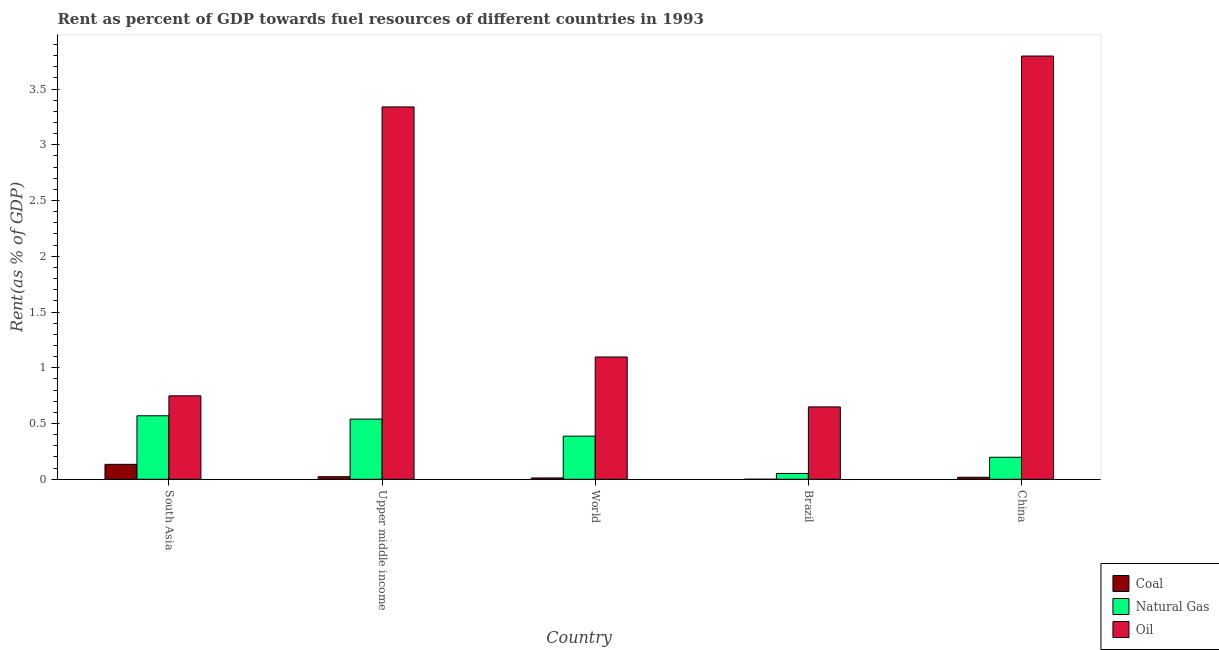How many different coloured bars are there?
Your answer should be very brief. 3. Are the number of bars on each tick of the X-axis equal?
Provide a short and direct response. Yes. In how many cases, is the number of bars for a given country not equal to the number of legend labels?
Offer a terse response. 0. What is the rent towards natural gas in World?
Your answer should be compact. 0.39. Across all countries, what is the maximum rent towards oil?
Provide a succinct answer. 3.8. Across all countries, what is the minimum rent towards coal?
Your answer should be very brief. 0. In which country was the rent towards coal maximum?
Give a very brief answer. South Asia. In which country was the rent towards natural gas minimum?
Make the answer very short. Brazil. What is the total rent towards coal in the graph?
Offer a terse response. 0.19. What is the difference between the rent towards natural gas in Brazil and that in China?
Make the answer very short. -0.15. What is the difference between the rent towards oil in Upper middle income and the rent towards natural gas in World?
Keep it short and to the point. 2.95. What is the average rent towards coal per country?
Offer a terse response. 0.04. What is the difference between the rent towards oil and rent towards coal in Brazil?
Provide a short and direct response. 0.65. In how many countries, is the rent towards oil greater than 0.8 %?
Your answer should be very brief. 3. What is the ratio of the rent towards oil in China to that in World?
Give a very brief answer. 3.46. Is the rent towards coal in South Asia less than that in World?
Offer a very short reply. No. Is the difference between the rent towards natural gas in Brazil and South Asia greater than the difference between the rent towards oil in Brazil and South Asia?
Your response must be concise. No. What is the difference between the highest and the second highest rent towards natural gas?
Provide a succinct answer. 0.03. What is the difference between the highest and the lowest rent towards natural gas?
Offer a terse response. 0.52. In how many countries, is the rent towards natural gas greater than the average rent towards natural gas taken over all countries?
Provide a short and direct response. 3. What does the 3rd bar from the left in Upper middle income represents?
Make the answer very short. Oil. What does the 1st bar from the right in China represents?
Your response must be concise. Oil. What is the difference between two consecutive major ticks on the Y-axis?
Your answer should be compact. 0.5. What is the title of the graph?
Offer a very short reply. Rent as percent of GDP towards fuel resources of different countries in 1993. Does "Agriculture" appear as one of the legend labels in the graph?
Your answer should be very brief. No. What is the label or title of the Y-axis?
Provide a succinct answer. Rent(as % of GDP). What is the Rent(as % of GDP) of Coal in South Asia?
Your response must be concise. 0.13. What is the Rent(as % of GDP) in Natural Gas in South Asia?
Provide a succinct answer. 0.57. What is the Rent(as % of GDP) in Oil in South Asia?
Your answer should be very brief. 0.75. What is the Rent(as % of GDP) of Coal in Upper middle income?
Your answer should be very brief. 0.02. What is the Rent(as % of GDP) of Natural Gas in Upper middle income?
Give a very brief answer. 0.54. What is the Rent(as % of GDP) of Oil in Upper middle income?
Give a very brief answer. 3.34. What is the Rent(as % of GDP) of Coal in World?
Make the answer very short. 0.01. What is the Rent(as % of GDP) of Natural Gas in World?
Offer a terse response. 0.39. What is the Rent(as % of GDP) in Oil in World?
Your response must be concise. 1.1. What is the Rent(as % of GDP) in Coal in Brazil?
Your response must be concise. 0. What is the Rent(as % of GDP) of Natural Gas in Brazil?
Provide a short and direct response. 0.05. What is the Rent(as % of GDP) in Oil in Brazil?
Provide a short and direct response. 0.65. What is the Rent(as % of GDP) of Coal in China?
Ensure brevity in your answer.  0.02. What is the Rent(as % of GDP) in Natural Gas in China?
Give a very brief answer. 0.2. What is the Rent(as % of GDP) of Oil in China?
Ensure brevity in your answer.  3.8. Across all countries, what is the maximum Rent(as % of GDP) in Coal?
Ensure brevity in your answer.  0.13. Across all countries, what is the maximum Rent(as % of GDP) of Natural Gas?
Keep it short and to the point. 0.57. Across all countries, what is the maximum Rent(as % of GDP) of Oil?
Your answer should be very brief. 3.8. Across all countries, what is the minimum Rent(as % of GDP) in Coal?
Give a very brief answer. 0. Across all countries, what is the minimum Rent(as % of GDP) in Natural Gas?
Ensure brevity in your answer.  0.05. Across all countries, what is the minimum Rent(as % of GDP) of Oil?
Offer a very short reply. 0.65. What is the total Rent(as % of GDP) in Coal in the graph?
Provide a succinct answer. 0.19. What is the total Rent(as % of GDP) of Natural Gas in the graph?
Provide a short and direct response. 1.75. What is the total Rent(as % of GDP) in Oil in the graph?
Your response must be concise. 9.63. What is the difference between the Rent(as % of GDP) of Coal in South Asia and that in Upper middle income?
Provide a short and direct response. 0.11. What is the difference between the Rent(as % of GDP) of Natural Gas in South Asia and that in Upper middle income?
Offer a very short reply. 0.03. What is the difference between the Rent(as % of GDP) of Oil in South Asia and that in Upper middle income?
Your response must be concise. -2.59. What is the difference between the Rent(as % of GDP) in Coal in South Asia and that in World?
Make the answer very short. 0.12. What is the difference between the Rent(as % of GDP) in Natural Gas in South Asia and that in World?
Offer a very short reply. 0.18. What is the difference between the Rent(as % of GDP) of Oil in South Asia and that in World?
Provide a short and direct response. -0.35. What is the difference between the Rent(as % of GDP) of Coal in South Asia and that in Brazil?
Make the answer very short. 0.13. What is the difference between the Rent(as % of GDP) of Natural Gas in South Asia and that in Brazil?
Provide a succinct answer. 0.52. What is the difference between the Rent(as % of GDP) in Oil in South Asia and that in Brazil?
Make the answer very short. 0.1. What is the difference between the Rent(as % of GDP) in Coal in South Asia and that in China?
Your answer should be very brief. 0.12. What is the difference between the Rent(as % of GDP) in Natural Gas in South Asia and that in China?
Your answer should be very brief. 0.37. What is the difference between the Rent(as % of GDP) of Oil in South Asia and that in China?
Make the answer very short. -3.05. What is the difference between the Rent(as % of GDP) in Coal in Upper middle income and that in World?
Your answer should be compact. 0.01. What is the difference between the Rent(as % of GDP) in Natural Gas in Upper middle income and that in World?
Ensure brevity in your answer.  0.15. What is the difference between the Rent(as % of GDP) of Oil in Upper middle income and that in World?
Ensure brevity in your answer.  2.24. What is the difference between the Rent(as % of GDP) of Coal in Upper middle income and that in Brazil?
Offer a very short reply. 0.02. What is the difference between the Rent(as % of GDP) of Natural Gas in Upper middle income and that in Brazil?
Your answer should be very brief. 0.49. What is the difference between the Rent(as % of GDP) in Oil in Upper middle income and that in Brazil?
Make the answer very short. 2.69. What is the difference between the Rent(as % of GDP) in Coal in Upper middle income and that in China?
Offer a terse response. 0.01. What is the difference between the Rent(as % of GDP) of Natural Gas in Upper middle income and that in China?
Make the answer very short. 0.34. What is the difference between the Rent(as % of GDP) in Oil in Upper middle income and that in China?
Your answer should be very brief. -0.46. What is the difference between the Rent(as % of GDP) in Coal in World and that in Brazil?
Ensure brevity in your answer.  0.01. What is the difference between the Rent(as % of GDP) in Natural Gas in World and that in Brazil?
Your answer should be very brief. 0.33. What is the difference between the Rent(as % of GDP) of Oil in World and that in Brazil?
Offer a terse response. 0.45. What is the difference between the Rent(as % of GDP) in Coal in World and that in China?
Make the answer very short. -0.01. What is the difference between the Rent(as % of GDP) of Natural Gas in World and that in China?
Make the answer very short. 0.19. What is the difference between the Rent(as % of GDP) in Oil in World and that in China?
Keep it short and to the point. -2.7. What is the difference between the Rent(as % of GDP) of Coal in Brazil and that in China?
Your answer should be very brief. -0.02. What is the difference between the Rent(as % of GDP) in Natural Gas in Brazil and that in China?
Provide a succinct answer. -0.15. What is the difference between the Rent(as % of GDP) in Oil in Brazil and that in China?
Ensure brevity in your answer.  -3.15. What is the difference between the Rent(as % of GDP) of Coal in South Asia and the Rent(as % of GDP) of Natural Gas in Upper middle income?
Make the answer very short. -0.41. What is the difference between the Rent(as % of GDP) in Coal in South Asia and the Rent(as % of GDP) in Oil in Upper middle income?
Your response must be concise. -3.21. What is the difference between the Rent(as % of GDP) of Natural Gas in South Asia and the Rent(as % of GDP) of Oil in Upper middle income?
Make the answer very short. -2.77. What is the difference between the Rent(as % of GDP) in Coal in South Asia and the Rent(as % of GDP) in Natural Gas in World?
Make the answer very short. -0.25. What is the difference between the Rent(as % of GDP) of Coal in South Asia and the Rent(as % of GDP) of Oil in World?
Make the answer very short. -0.96. What is the difference between the Rent(as % of GDP) of Natural Gas in South Asia and the Rent(as % of GDP) of Oil in World?
Give a very brief answer. -0.53. What is the difference between the Rent(as % of GDP) in Coal in South Asia and the Rent(as % of GDP) in Natural Gas in Brazil?
Keep it short and to the point. 0.08. What is the difference between the Rent(as % of GDP) in Coal in South Asia and the Rent(as % of GDP) in Oil in Brazil?
Provide a short and direct response. -0.52. What is the difference between the Rent(as % of GDP) in Natural Gas in South Asia and the Rent(as % of GDP) in Oil in Brazil?
Make the answer very short. -0.08. What is the difference between the Rent(as % of GDP) of Coal in South Asia and the Rent(as % of GDP) of Natural Gas in China?
Provide a short and direct response. -0.06. What is the difference between the Rent(as % of GDP) in Coal in South Asia and the Rent(as % of GDP) in Oil in China?
Make the answer very short. -3.66. What is the difference between the Rent(as % of GDP) of Natural Gas in South Asia and the Rent(as % of GDP) of Oil in China?
Your answer should be compact. -3.23. What is the difference between the Rent(as % of GDP) in Coal in Upper middle income and the Rent(as % of GDP) in Natural Gas in World?
Offer a very short reply. -0.36. What is the difference between the Rent(as % of GDP) in Coal in Upper middle income and the Rent(as % of GDP) in Oil in World?
Provide a succinct answer. -1.07. What is the difference between the Rent(as % of GDP) in Natural Gas in Upper middle income and the Rent(as % of GDP) in Oil in World?
Offer a very short reply. -0.56. What is the difference between the Rent(as % of GDP) in Coal in Upper middle income and the Rent(as % of GDP) in Natural Gas in Brazil?
Offer a very short reply. -0.03. What is the difference between the Rent(as % of GDP) of Coal in Upper middle income and the Rent(as % of GDP) of Oil in Brazil?
Offer a terse response. -0.63. What is the difference between the Rent(as % of GDP) of Natural Gas in Upper middle income and the Rent(as % of GDP) of Oil in Brazil?
Your response must be concise. -0.11. What is the difference between the Rent(as % of GDP) of Coal in Upper middle income and the Rent(as % of GDP) of Natural Gas in China?
Keep it short and to the point. -0.17. What is the difference between the Rent(as % of GDP) of Coal in Upper middle income and the Rent(as % of GDP) of Oil in China?
Provide a succinct answer. -3.77. What is the difference between the Rent(as % of GDP) of Natural Gas in Upper middle income and the Rent(as % of GDP) of Oil in China?
Give a very brief answer. -3.26. What is the difference between the Rent(as % of GDP) of Coal in World and the Rent(as % of GDP) of Natural Gas in Brazil?
Provide a succinct answer. -0.04. What is the difference between the Rent(as % of GDP) of Coal in World and the Rent(as % of GDP) of Oil in Brazil?
Offer a terse response. -0.64. What is the difference between the Rent(as % of GDP) in Natural Gas in World and the Rent(as % of GDP) in Oil in Brazil?
Your response must be concise. -0.26. What is the difference between the Rent(as % of GDP) in Coal in World and the Rent(as % of GDP) in Natural Gas in China?
Offer a terse response. -0.19. What is the difference between the Rent(as % of GDP) of Coal in World and the Rent(as % of GDP) of Oil in China?
Your response must be concise. -3.78. What is the difference between the Rent(as % of GDP) in Natural Gas in World and the Rent(as % of GDP) in Oil in China?
Give a very brief answer. -3.41. What is the difference between the Rent(as % of GDP) of Coal in Brazil and the Rent(as % of GDP) of Natural Gas in China?
Make the answer very short. -0.2. What is the difference between the Rent(as % of GDP) in Coal in Brazil and the Rent(as % of GDP) in Oil in China?
Make the answer very short. -3.8. What is the difference between the Rent(as % of GDP) in Natural Gas in Brazil and the Rent(as % of GDP) in Oil in China?
Offer a terse response. -3.74. What is the average Rent(as % of GDP) of Coal per country?
Your response must be concise. 0.04. What is the average Rent(as % of GDP) of Natural Gas per country?
Provide a short and direct response. 0.35. What is the average Rent(as % of GDP) of Oil per country?
Make the answer very short. 1.93. What is the difference between the Rent(as % of GDP) of Coal and Rent(as % of GDP) of Natural Gas in South Asia?
Your answer should be very brief. -0.44. What is the difference between the Rent(as % of GDP) of Coal and Rent(as % of GDP) of Oil in South Asia?
Your answer should be very brief. -0.61. What is the difference between the Rent(as % of GDP) in Natural Gas and Rent(as % of GDP) in Oil in South Asia?
Provide a succinct answer. -0.18. What is the difference between the Rent(as % of GDP) of Coal and Rent(as % of GDP) of Natural Gas in Upper middle income?
Offer a terse response. -0.52. What is the difference between the Rent(as % of GDP) of Coal and Rent(as % of GDP) of Oil in Upper middle income?
Your answer should be very brief. -3.32. What is the difference between the Rent(as % of GDP) of Natural Gas and Rent(as % of GDP) of Oil in Upper middle income?
Give a very brief answer. -2.8. What is the difference between the Rent(as % of GDP) of Coal and Rent(as % of GDP) of Natural Gas in World?
Your answer should be compact. -0.37. What is the difference between the Rent(as % of GDP) of Coal and Rent(as % of GDP) of Oil in World?
Offer a very short reply. -1.08. What is the difference between the Rent(as % of GDP) in Natural Gas and Rent(as % of GDP) in Oil in World?
Your answer should be very brief. -0.71. What is the difference between the Rent(as % of GDP) in Coal and Rent(as % of GDP) in Natural Gas in Brazil?
Your response must be concise. -0.05. What is the difference between the Rent(as % of GDP) of Coal and Rent(as % of GDP) of Oil in Brazil?
Your response must be concise. -0.65. What is the difference between the Rent(as % of GDP) of Natural Gas and Rent(as % of GDP) of Oil in Brazil?
Offer a very short reply. -0.6. What is the difference between the Rent(as % of GDP) of Coal and Rent(as % of GDP) of Natural Gas in China?
Keep it short and to the point. -0.18. What is the difference between the Rent(as % of GDP) of Coal and Rent(as % of GDP) of Oil in China?
Provide a short and direct response. -3.78. What is the difference between the Rent(as % of GDP) of Natural Gas and Rent(as % of GDP) of Oil in China?
Your response must be concise. -3.6. What is the ratio of the Rent(as % of GDP) in Coal in South Asia to that in Upper middle income?
Keep it short and to the point. 5.83. What is the ratio of the Rent(as % of GDP) of Natural Gas in South Asia to that in Upper middle income?
Your response must be concise. 1.06. What is the ratio of the Rent(as % of GDP) in Oil in South Asia to that in Upper middle income?
Your answer should be very brief. 0.22. What is the ratio of the Rent(as % of GDP) in Coal in South Asia to that in World?
Keep it short and to the point. 11.19. What is the ratio of the Rent(as % of GDP) in Natural Gas in South Asia to that in World?
Your answer should be very brief. 1.47. What is the ratio of the Rent(as % of GDP) of Oil in South Asia to that in World?
Your answer should be very brief. 0.68. What is the ratio of the Rent(as % of GDP) in Coal in South Asia to that in Brazil?
Offer a very short reply. 765.05. What is the ratio of the Rent(as % of GDP) in Natural Gas in South Asia to that in Brazil?
Give a very brief answer. 10.88. What is the ratio of the Rent(as % of GDP) of Oil in South Asia to that in Brazil?
Ensure brevity in your answer.  1.15. What is the ratio of the Rent(as % of GDP) in Coal in South Asia to that in China?
Make the answer very short. 7.48. What is the ratio of the Rent(as % of GDP) in Natural Gas in South Asia to that in China?
Give a very brief answer. 2.88. What is the ratio of the Rent(as % of GDP) in Oil in South Asia to that in China?
Your answer should be compact. 0.2. What is the ratio of the Rent(as % of GDP) of Coal in Upper middle income to that in World?
Offer a very short reply. 1.92. What is the ratio of the Rent(as % of GDP) of Natural Gas in Upper middle income to that in World?
Offer a terse response. 1.4. What is the ratio of the Rent(as % of GDP) of Oil in Upper middle income to that in World?
Give a very brief answer. 3.04. What is the ratio of the Rent(as % of GDP) of Coal in Upper middle income to that in Brazil?
Offer a terse response. 131.32. What is the ratio of the Rent(as % of GDP) in Natural Gas in Upper middle income to that in Brazil?
Give a very brief answer. 10.31. What is the ratio of the Rent(as % of GDP) of Oil in Upper middle income to that in Brazil?
Offer a very short reply. 5.15. What is the ratio of the Rent(as % of GDP) in Coal in Upper middle income to that in China?
Your response must be concise. 1.28. What is the ratio of the Rent(as % of GDP) of Natural Gas in Upper middle income to that in China?
Ensure brevity in your answer.  2.73. What is the ratio of the Rent(as % of GDP) of Oil in Upper middle income to that in China?
Your answer should be very brief. 0.88. What is the ratio of the Rent(as % of GDP) of Coal in World to that in Brazil?
Provide a succinct answer. 68.39. What is the ratio of the Rent(as % of GDP) of Natural Gas in World to that in Brazil?
Provide a short and direct response. 7.39. What is the ratio of the Rent(as % of GDP) in Oil in World to that in Brazil?
Ensure brevity in your answer.  1.69. What is the ratio of the Rent(as % of GDP) of Coal in World to that in China?
Give a very brief answer. 0.67. What is the ratio of the Rent(as % of GDP) of Natural Gas in World to that in China?
Make the answer very short. 1.96. What is the ratio of the Rent(as % of GDP) of Oil in World to that in China?
Provide a succinct answer. 0.29. What is the ratio of the Rent(as % of GDP) of Coal in Brazil to that in China?
Keep it short and to the point. 0.01. What is the ratio of the Rent(as % of GDP) in Natural Gas in Brazil to that in China?
Ensure brevity in your answer.  0.27. What is the ratio of the Rent(as % of GDP) in Oil in Brazil to that in China?
Your response must be concise. 0.17. What is the difference between the highest and the second highest Rent(as % of GDP) in Coal?
Offer a very short reply. 0.11. What is the difference between the highest and the second highest Rent(as % of GDP) of Natural Gas?
Your answer should be very brief. 0.03. What is the difference between the highest and the second highest Rent(as % of GDP) of Oil?
Your response must be concise. 0.46. What is the difference between the highest and the lowest Rent(as % of GDP) of Coal?
Offer a terse response. 0.13. What is the difference between the highest and the lowest Rent(as % of GDP) in Natural Gas?
Ensure brevity in your answer.  0.52. What is the difference between the highest and the lowest Rent(as % of GDP) in Oil?
Offer a very short reply. 3.15. 